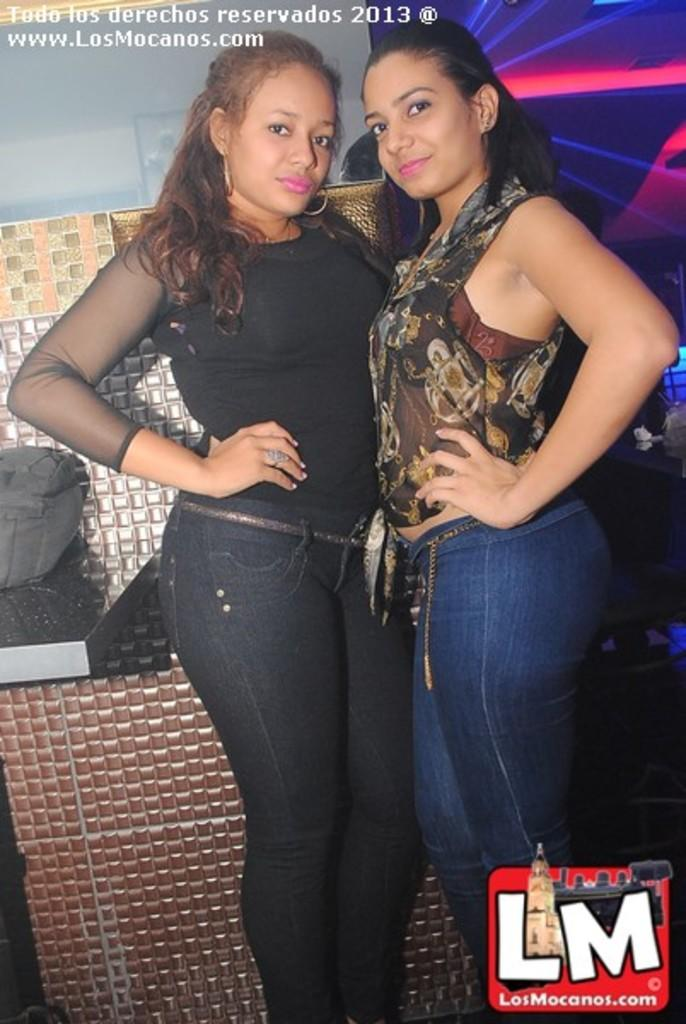How many people are in the image? There are two women in the image. What are the women doing in the image? The women are standing. What are the women wearing in the image? The women are wearing different color dresses. What can be seen behind the women in the image? There is a different color background in the image. What type of engine is powering the unit in the image? There is no engine or unit present in the image; it features two women standing in front of a different color background. 